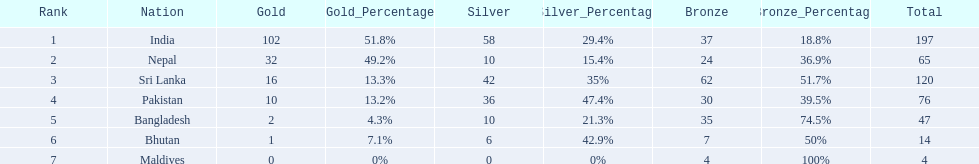What were the total amount won of medals by nations in the 1999 south asian games? 197, 65, 120, 76, 47, 14, 4. Which amount was the lowest? 4. Which nation had this amount? Maldives. 